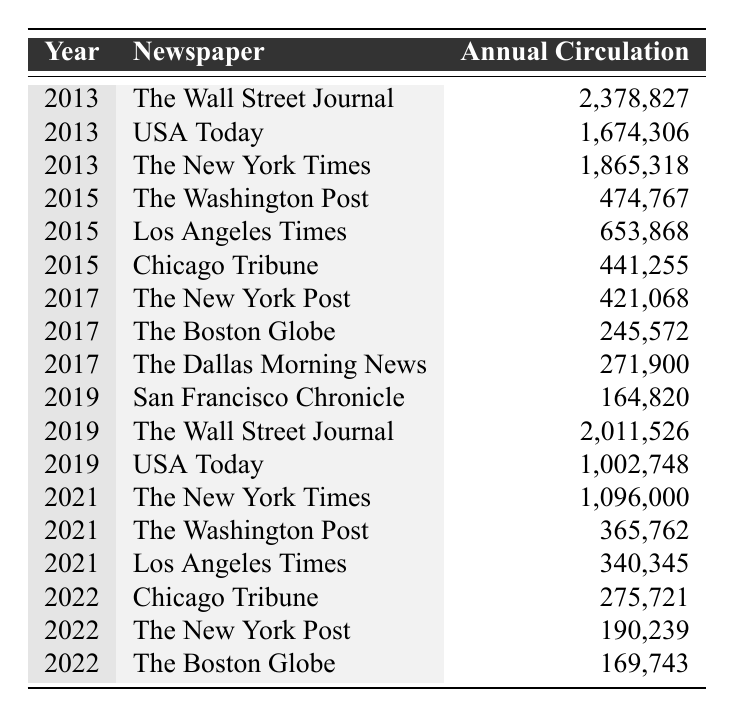What was the annual circulation of The New York Times in 2021? In the row corresponding to the year 2021 and the newspaper The New York Times, the annual circulation is listed as 1,096,000.
Answer: 1,096,000 Which newspaper had the highest annual circulation in 2013? Looking at the data for 2013, The Wall Street Journal's annual circulation is 2,378,827, which is higher than that of USA Today and The New York Times.
Answer: The Wall Street Journal What is the difference in annual circulation between USA Today in 2013 and 2019? The annual circulation of USA Today in 2013 is 1,674,306, and in 2019, it is 1,002,748. The difference is calculated as 1,674,306 - 1,002,748 = 671,558.
Answer: 671,558 How many newspapers had an annual circulation of over 1 million in 2019? In 2019, two newspapers had over 1 million in annual circulation: The Wall Street Journal (2,011,526) and USA Today (1,002,748), while the others had less than that.
Answer: 2 What was the average annual circulation for the Chicago Tribune across all years provided? The Chicago Tribune's annual circulations are 441,255 (2015) and 275,721 (2022). Calculating the average: (441,255 + 275,721) / 2 = 358,488.
Answer: 358,488 Did The Boston Globe's annual circulation increase or decrease from 2017 to 2022? In 2017, The Boston Globe had an annual circulation of 245,572, and in 2022, it fell to 169,743. This indicates a decrease in circulation over that time.
Answer: Decrease Which newspaper had the lowest annual circulation in 2022, and what was that figure? From the data for 2022, The Boston Globe had the lowest annual circulation of 169,743 compared to Chicago Tribune and The New York Post.
Answer: The Boston Globe, 169,743 If we sum the annual circulations of all newspapers in 2015, what is the total? The annual circulations for 2015 are: The Washington Post (474,767), Los Angeles Times (653,868), and Chicago Tribune (441,255). Summing these values gives 474,767 + 653,868 + 441,255 = 1,569,890.
Answer: 1,569,890 What trend can be seen in the annual circulation of The Washington Post from 2015 to 2021? In 2015, The Washington Post had an annual circulation of 474,767, which decreased to 365,762 in 2021. This indicates a downward trend over the years from 2015 to 2021.
Answer: Downward trend Which newspaper consistently appears in the data for the years 2013, 2019, and 2021, and what was its circulation in those years? The Wall Street Journal appears in 2013 (2,378,827), 2019 (2,011,526), and does not appear in 2021. Instead, The New York Times consistently appears in those years with 1,865,318 (2013), 1,096,000 (2021).
Answer: The New York Times; 1,865,318 (2013), 1,096,000 (2021) 